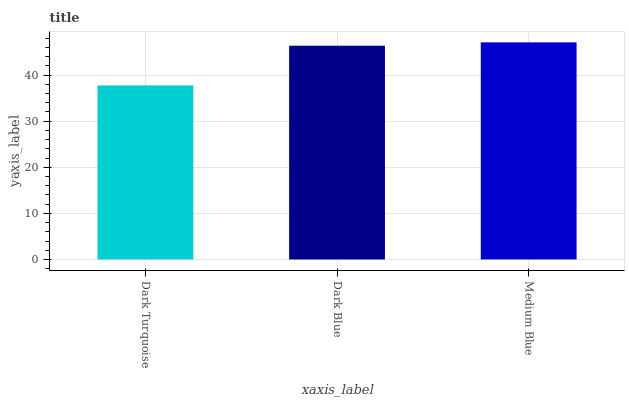Is Dark Turquoise the minimum?
Answer yes or no. Yes. Is Medium Blue the maximum?
Answer yes or no. Yes. Is Dark Blue the minimum?
Answer yes or no. No. Is Dark Blue the maximum?
Answer yes or no. No. Is Dark Blue greater than Dark Turquoise?
Answer yes or no. Yes. Is Dark Turquoise less than Dark Blue?
Answer yes or no. Yes. Is Dark Turquoise greater than Dark Blue?
Answer yes or no. No. Is Dark Blue less than Dark Turquoise?
Answer yes or no. No. Is Dark Blue the high median?
Answer yes or no. Yes. Is Dark Blue the low median?
Answer yes or no. Yes. Is Dark Turquoise the high median?
Answer yes or no. No. Is Medium Blue the low median?
Answer yes or no. No. 